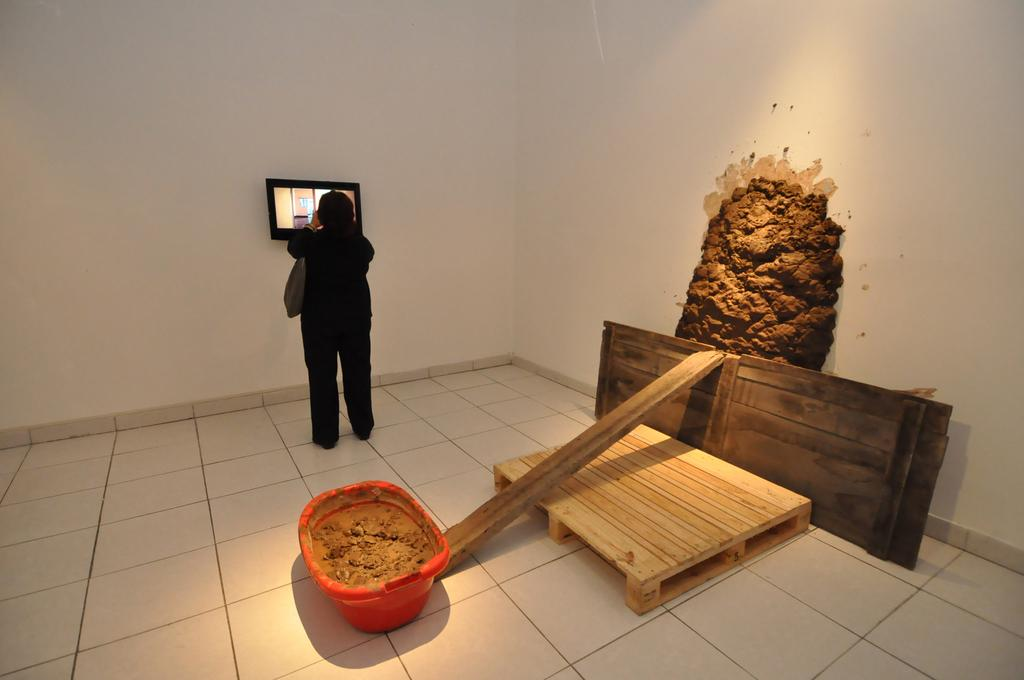What is the main subject in the image? There is a person standing in front of a wall in the image. What can be seen behind the person? Wooden planks are visible behind the person, and there is a tub with mud present. What is on the wall in the image? There is a frame on the wall in the image. What type of breakfast is being served on the wall in the image? There is no breakfast present in the image; the wall features a frame. 